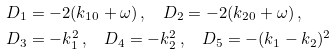<formula> <loc_0><loc_0><loc_500><loc_500>& D _ { 1 } = - 2 ( k _ { 1 0 } + \omega ) \, , \quad D _ { 2 } = - 2 ( k _ { 2 0 } + \omega ) \, , \\ & D _ { 3 } = - k _ { 1 } ^ { 2 } \, , \quad D _ { 4 } = - k _ { 2 } ^ { 2 } \, , \quad D _ { 5 } = - ( k _ { 1 } - k _ { 2 } ) ^ { 2 }</formula> 